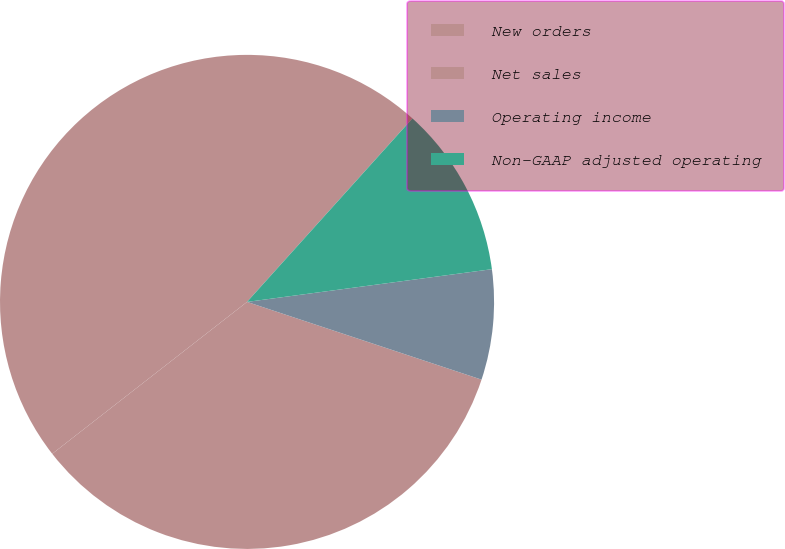Convert chart to OTSL. <chart><loc_0><loc_0><loc_500><loc_500><pie_chart><fcel>New orders<fcel>Net sales<fcel>Operating income<fcel>Non-GAAP adjusted operating<nl><fcel>47.22%<fcel>34.37%<fcel>7.21%<fcel>11.21%<nl></chart> 